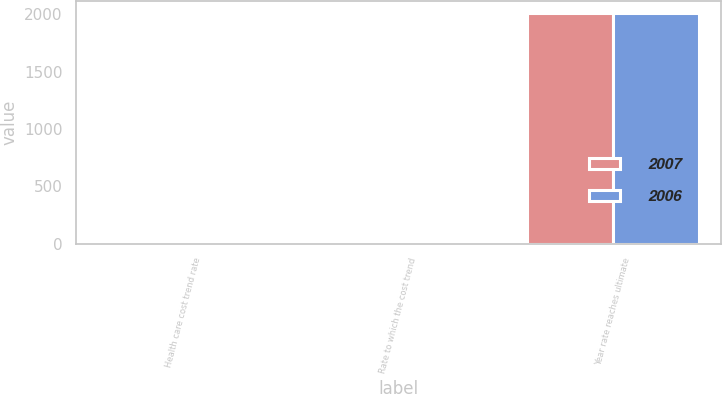<chart> <loc_0><loc_0><loc_500><loc_500><stacked_bar_chart><ecel><fcel>Health care cost trend rate<fcel>Rate to which the cost trend<fcel>Year rate reaches ultimate<nl><fcel>2007<fcel>9<fcel>5<fcel>2012<nl><fcel>2006<fcel>10<fcel>5<fcel>2012<nl></chart> 